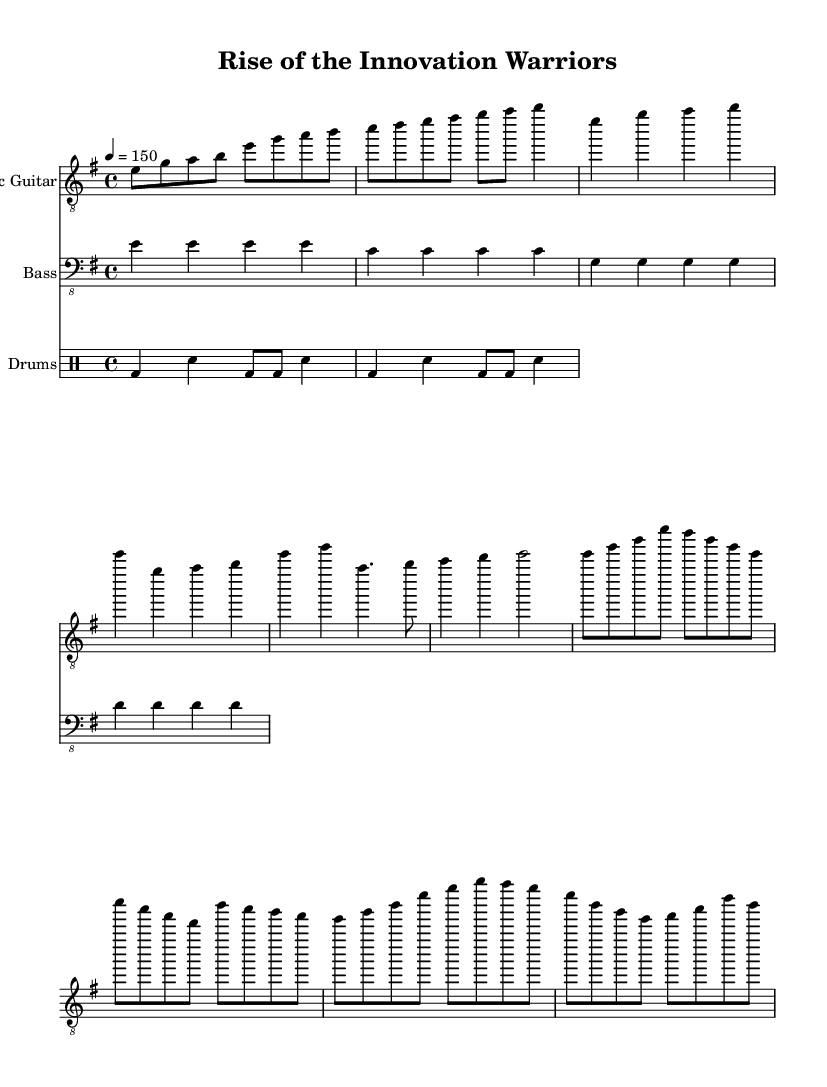What is the key signature of this music? The key signature is E minor, which contains one sharp (F#). This can be determined by looking at the key signature indicated at the beginning of the sheet music.
Answer: E minor What is the time signature of this music? The time signature is 4/4, as explicitly noted at the beginning of the score. This means there are four beats in a measure and the quarter note gets one beat.
Answer: 4/4 What is the tempo marking for this piece? The tempo marking is 4 = 150, indicating that the quarter note is to be played at a speed of 150 beats per minute. This marking is located at the very beginning of the music score.
Answer: 150 How many measures are in the chorus section? The chorus section consists of 8 measures, as counted from the notation provided in the score that outlines the chorus. Each measure is separated by a vertical line.
Answer: 8 What is the predominant instrument shown in the score? The predominant instrument shown in the score is the electric guitar, as it is the first staff listed and prominently features the melody and main riffs throughout the piece.
Answer: Electric Guitar What type of rhythm is featured in the drum part? The rhythm is a basic rock beat, characterized by a combination of bass drum hits and snare hits, typical for metal music styles. This can be discerned from the rhythmic structure laid out in the drum part.
Answer: Basic rock beat How does the bass line correspond with the electric guitar part? The bass line closely follows the root notes of the electric guitar melody, providing harmonic support and rhythm alignment with the guitar parts throughout the score. This is determined by comparing the notes played in both parts.
Answer: Harmonic support 